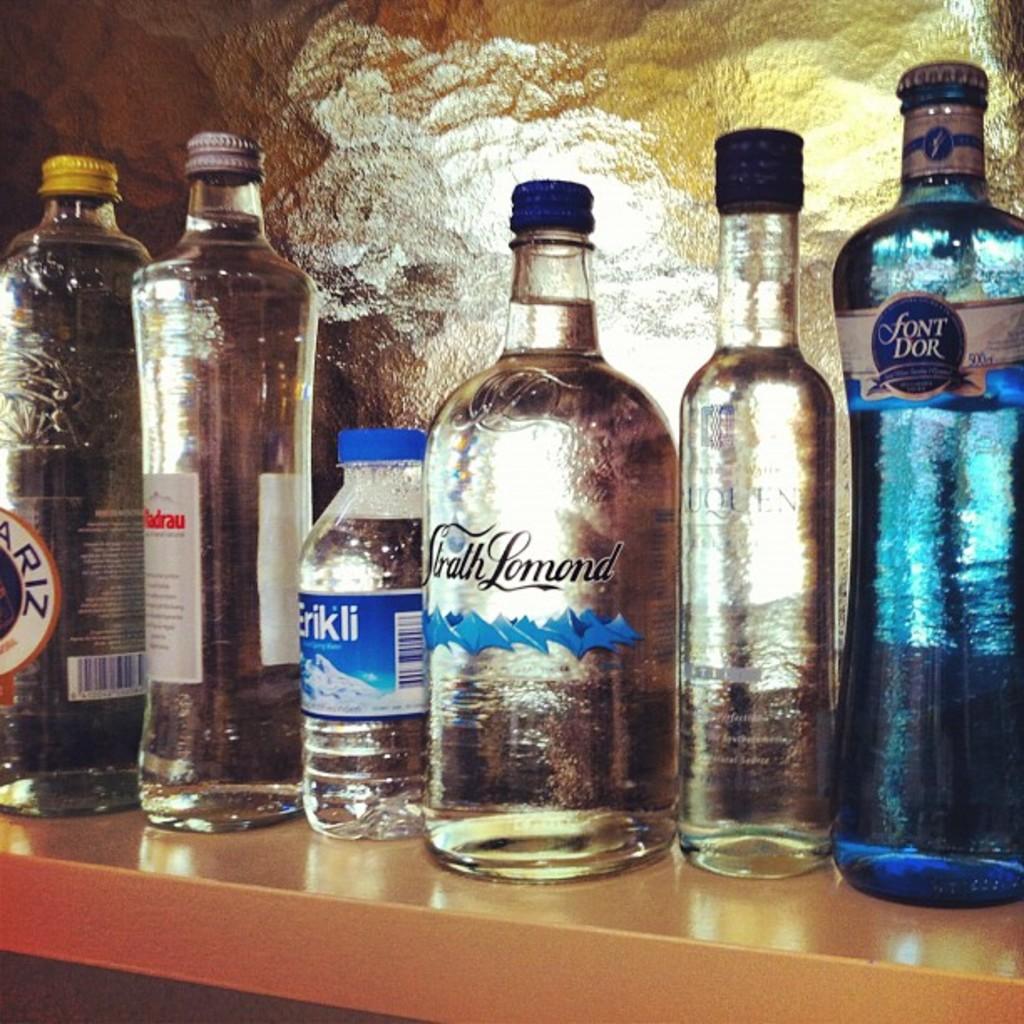How many ml is the bottle on the far right?
Give a very brief answer. 500. 